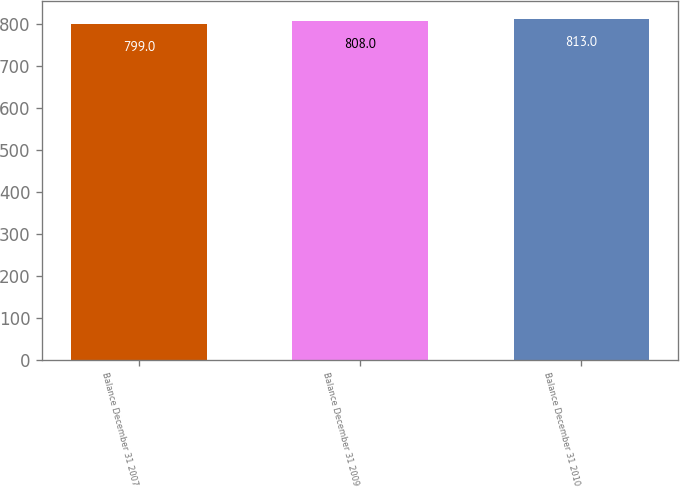Convert chart. <chart><loc_0><loc_0><loc_500><loc_500><bar_chart><fcel>Balance December 31 2007<fcel>Balance December 31 2009<fcel>Balance December 31 2010<nl><fcel>799<fcel>808<fcel>813<nl></chart> 